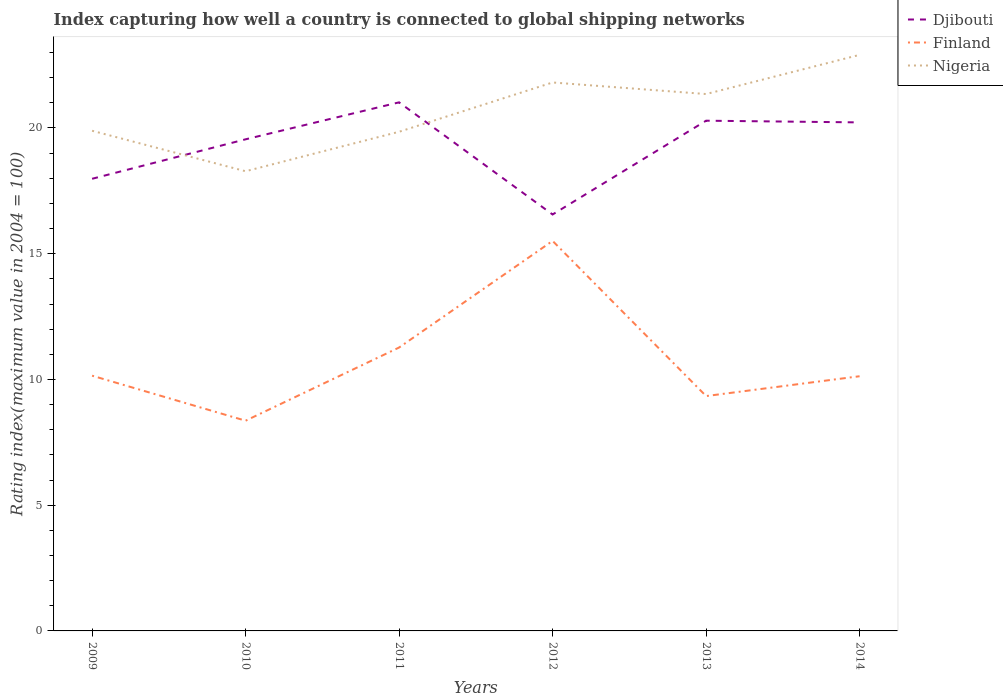Does the line corresponding to Finland intersect with the line corresponding to Djibouti?
Ensure brevity in your answer.  No. Across all years, what is the maximum rating index in Nigeria?
Offer a terse response. 18.28. What is the total rating index in Djibouti in the graph?
Make the answer very short. -2.24. What is the difference between the highest and the second highest rating index in Nigeria?
Your response must be concise. 4.63. What is the difference between the highest and the lowest rating index in Djibouti?
Your answer should be very brief. 4. How many years are there in the graph?
Offer a terse response. 6. What is the difference between two consecutive major ticks on the Y-axis?
Offer a very short reply. 5. Does the graph contain grids?
Your response must be concise. No. Where does the legend appear in the graph?
Ensure brevity in your answer.  Top right. What is the title of the graph?
Provide a succinct answer. Index capturing how well a country is connected to global shipping networks. Does "High income" appear as one of the legend labels in the graph?
Provide a succinct answer. No. What is the label or title of the Y-axis?
Provide a short and direct response. Rating index(maximum value in 2004 = 100). What is the Rating index(maximum value in 2004 = 100) in Djibouti in 2009?
Keep it short and to the point. 17.98. What is the Rating index(maximum value in 2004 = 100) of Finland in 2009?
Your answer should be very brief. 10.15. What is the Rating index(maximum value in 2004 = 100) in Nigeria in 2009?
Keep it short and to the point. 19.89. What is the Rating index(maximum value in 2004 = 100) of Djibouti in 2010?
Make the answer very short. 19.55. What is the Rating index(maximum value in 2004 = 100) of Finland in 2010?
Make the answer very short. 8.36. What is the Rating index(maximum value in 2004 = 100) of Nigeria in 2010?
Offer a terse response. 18.28. What is the Rating index(maximum value in 2004 = 100) in Djibouti in 2011?
Keep it short and to the point. 21.02. What is the Rating index(maximum value in 2004 = 100) in Finland in 2011?
Offer a very short reply. 11.27. What is the Rating index(maximum value in 2004 = 100) of Nigeria in 2011?
Provide a short and direct response. 19.85. What is the Rating index(maximum value in 2004 = 100) in Djibouti in 2012?
Keep it short and to the point. 16.56. What is the Rating index(maximum value in 2004 = 100) of Finland in 2012?
Your answer should be compact. 15.51. What is the Rating index(maximum value in 2004 = 100) of Nigeria in 2012?
Make the answer very short. 21.81. What is the Rating index(maximum value in 2004 = 100) in Djibouti in 2013?
Make the answer very short. 20.29. What is the Rating index(maximum value in 2004 = 100) of Finland in 2013?
Offer a terse response. 9.34. What is the Rating index(maximum value in 2004 = 100) in Nigeria in 2013?
Your answer should be compact. 21.35. What is the Rating index(maximum value in 2004 = 100) in Djibouti in 2014?
Your response must be concise. 20.22. What is the Rating index(maximum value in 2004 = 100) in Finland in 2014?
Offer a terse response. 10.13. What is the Rating index(maximum value in 2004 = 100) of Nigeria in 2014?
Your response must be concise. 22.91. Across all years, what is the maximum Rating index(maximum value in 2004 = 100) of Djibouti?
Provide a short and direct response. 21.02. Across all years, what is the maximum Rating index(maximum value in 2004 = 100) of Finland?
Ensure brevity in your answer.  15.51. Across all years, what is the maximum Rating index(maximum value in 2004 = 100) of Nigeria?
Provide a short and direct response. 22.91. Across all years, what is the minimum Rating index(maximum value in 2004 = 100) in Djibouti?
Make the answer very short. 16.56. Across all years, what is the minimum Rating index(maximum value in 2004 = 100) in Finland?
Make the answer very short. 8.36. Across all years, what is the minimum Rating index(maximum value in 2004 = 100) of Nigeria?
Your answer should be very brief. 18.28. What is the total Rating index(maximum value in 2004 = 100) in Djibouti in the graph?
Offer a terse response. 115.62. What is the total Rating index(maximum value in 2004 = 100) in Finland in the graph?
Offer a very short reply. 64.76. What is the total Rating index(maximum value in 2004 = 100) in Nigeria in the graph?
Your answer should be compact. 124.09. What is the difference between the Rating index(maximum value in 2004 = 100) in Djibouti in 2009 and that in 2010?
Your answer should be compact. -1.57. What is the difference between the Rating index(maximum value in 2004 = 100) of Finland in 2009 and that in 2010?
Provide a succinct answer. 1.79. What is the difference between the Rating index(maximum value in 2004 = 100) in Nigeria in 2009 and that in 2010?
Offer a terse response. 1.61. What is the difference between the Rating index(maximum value in 2004 = 100) in Djibouti in 2009 and that in 2011?
Provide a succinct answer. -3.04. What is the difference between the Rating index(maximum value in 2004 = 100) in Finland in 2009 and that in 2011?
Make the answer very short. -1.12. What is the difference between the Rating index(maximum value in 2004 = 100) in Nigeria in 2009 and that in 2011?
Give a very brief answer. 0.04. What is the difference between the Rating index(maximum value in 2004 = 100) of Djibouti in 2009 and that in 2012?
Provide a succinct answer. 1.42. What is the difference between the Rating index(maximum value in 2004 = 100) in Finland in 2009 and that in 2012?
Your answer should be very brief. -5.36. What is the difference between the Rating index(maximum value in 2004 = 100) of Nigeria in 2009 and that in 2012?
Offer a very short reply. -1.92. What is the difference between the Rating index(maximum value in 2004 = 100) of Djibouti in 2009 and that in 2013?
Offer a very short reply. -2.31. What is the difference between the Rating index(maximum value in 2004 = 100) in Finland in 2009 and that in 2013?
Provide a succinct answer. 0.81. What is the difference between the Rating index(maximum value in 2004 = 100) of Nigeria in 2009 and that in 2013?
Ensure brevity in your answer.  -1.46. What is the difference between the Rating index(maximum value in 2004 = 100) of Djibouti in 2009 and that in 2014?
Your response must be concise. -2.24. What is the difference between the Rating index(maximum value in 2004 = 100) of Finland in 2009 and that in 2014?
Make the answer very short. 0.02. What is the difference between the Rating index(maximum value in 2004 = 100) of Nigeria in 2009 and that in 2014?
Provide a succinct answer. -3.02. What is the difference between the Rating index(maximum value in 2004 = 100) of Djibouti in 2010 and that in 2011?
Your answer should be very brief. -1.47. What is the difference between the Rating index(maximum value in 2004 = 100) of Finland in 2010 and that in 2011?
Offer a very short reply. -2.91. What is the difference between the Rating index(maximum value in 2004 = 100) of Nigeria in 2010 and that in 2011?
Make the answer very short. -1.57. What is the difference between the Rating index(maximum value in 2004 = 100) of Djibouti in 2010 and that in 2012?
Your answer should be very brief. 2.99. What is the difference between the Rating index(maximum value in 2004 = 100) in Finland in 2010 and that in 2012?
Ensure brevity in your answer.  -7.15. What is the difference between the Rating index(maximum value in 2004 = 100) of Nigeria in 2010 and that in 2012?
Keep it short and to the point. -3.53. What is the difference between the Rating index(maximum value in 2004 = 100) of Djibouti in 2010 and that in 2013?
Your response must be concise. -0.74. What is the difference between the Rating index(maximum value in 2004 = 100) of Finland in 2010 and that in 2013?
Ensure brevity in your answer.  -0.98. What is the difference between the Rating index(maximum value in 2004 = 100) of Nigeria in 2010 and that in 2013?
Offer a terse response. -3.07. What is the difference between the Rating index(maximum value in 2004 = 100) of Djibouti in 2010 and that in 2014?
Your answer should be very brief. -0.67. What is the difference between the Rating index(maximum value in 2004 = 100) in Finland in 2010 and that in 2014?
Your answer should be compact. -1.77. What is the difference between the Rating index(maximum value in 2004 = 100) in Nigeria in 2010 and that in 2014?
Provide a short and direct response. -4.63. What is the difference between the Rating index(maximum value in 2004 = 100) of Djibouti in 2011 and that in 2012?
Your answer should be very brief. 4.46. What is the difference between the Rating index(maximum value in 2004 = 100) of Finland in 2011 and that in 2012?
Ensure brevity in your answer.  -4.24. What is the difference between the Rating index(maximum value in 2004 = 100) of Nigeria in 2011 and that in 2012?
Your answer should be compact. -1.96. What is the difference between the Rating index(maximum value in 2004 = 100) of Djibouti in 2011 and that in 2013?
Ensure brevity in your answer.  0.73. What is the difference between the Rating index(maximum value in 2004 = 100) of Finland in 2011 and that in 2013?
Your response must be concise. 1.93. What is the difference between the Rating index(maximum value in 2004 = 100) in Nigeria in 2011 and that in 2013?
Make the answer very short. -1.5. What is the difference between the Rating index(maximum value in 2004 = 100) in Djibouti in 2011 and that in 2014?
Provide a short and direct response. 0.8. What is the difference between the Rating index(maximum value in 2004 = 100) of Finland in 2011 and that in 2014?
Your response must be concise. 1.14. What is the difference between the Rating index(maximum value in 2004 = 100) in Nigeria in 2011 and that in 2014?
Provide a short and direct response. -3.06. What is the difference between the Rating index(maximum value in 2004 = 100) in Djibouti in 2012 and that in 2013?
Your answer should be compact. -3.73. What is the difference between the Rating index(maximum value in 2004 = 100) in Finland in 2012 and that in 2013?
Keep it short and to the point. 6.17. What is the difference between the Rating index(maximum value in 2004 = 100) in Nigeria in 2012 and that in 2013?
Keep it short and to the point. 0.46. What is the difference between the Rating index(maximum value in 2004 = 100) in Djibouti in 2012 and that in 2014?
Ensure brevity in your answer.  -3.66. What is the difference between the Rating index(maximum value in 2004 = 100) in Finland in 2012 and that in 2014?
Ensure brevity in your answer.  5.38. What is the difference between the Rating index(maximum value in 2004 = 100) in Nigeria in 2012 and that in 2014?
Ensure brevity in your answer.  -1.1. What is the difference between the Rating index(maximum value in 2004 = 100) of Djibouti in 2013 and that in 2014?
Keep it short and to the point. 0.07. What is the difference between the Rating index(maximum value in 2004 = 100) of Finland in 2013 and that in 2014?
Provide a succinct answer. -0.79. What is the difference between the Rating index(maximum value in 2004 = 100) in Nigeria in 2013 and that in 2014?
Keep it short and to the point. -1.56. What is the difference between the Rating index(maximum value in 2004 = 100) in Djibouti in 2009 and the Rating index(maximum value in 2004 = 100) in Finland in 2010?
Provide a short and direct response. 9.62. What is the difference between the Rating index(maximum value in 2004 = 100) in Djibouti in 2009 and the Rating index(maximum value in 2004 = 100) in Nigeria in 2010?
Provide a succinct answer. -0.3. What is the difference between the Rating index(maximum value in 2004 = 100) in Finland in 2009 and the Rating index(maximum value in 2004 = 100) in Nigeria in 2010?
Provide a short and direct response. -8.13. What is the difference between the Rating index(maximum value in 2004 = 100) of Djibouti in 2009 and the Rating index(maximum value in 2004 = 100) of Finland in 2011?
Offer a very short reply. 6.71. What is the difference between the Rating index(maximum value in 2004 = 100) of Djibouti in 2009 and the Rating index(maximum value in 2004 = 100) of Nigeria in 2011?
Your answer should be compact. -1.87. What is the difference between the Rating index(maximum value in 2004 = 100) in Finland in 2009 and the Rating index(maximum value in 2004 = 100) in Nigeria in 2011?
Ensure brevity in your answer.  -9.7. What is the difference between the Rating index(maximum value in 2004 = 100) of Djibouti in 2009 and the Rating index(maximum value in 2004 = 100) of Finland in 2012?
Keep it short and to the point. 2.47. What is the difference between the Rating index(maximum value in 2004 = 100) of Djibouti in 2009 and the Rating index(maximum value in 2004 = 100) of Nigeria in 2012?
Your answer should be compact. -3.83. What is the difference between the Rating index(maximum value in 2004 = 100) of Finland in 2009 and the Rating index(maximum value in 2004 = 100) of Nigeria in 2012?
Provide a succinct answer. -11.66. What is the difference between the Rating index(maximum value in 2004 = 100) of Djibouti in 2009 and the Rating index(maximum value in 2004 = 100) of Finland in 2013?
Offer a terse response. 8.64. What is the difference between the Rating index(maximum value in 2004 = 100) of Djibouti in 2009 and the Rating index(maximum value in 2004 = 100) of Nigeria in 2013?
Make the answer very short. -3.37. What is the difference between the Rating index(maximum value in 2004 = 100) in Djibouti in 2009 and the Rating index(maximum value in 2004 = 100) in Finland in 2014?
Your answer should be very brief. 7.85. What is the difference between the Rating index(maximum value in 2004 = 100) in Djibouti in 2009 and the Rating index(maximum value in 2004 = 100) in Nigeria in 2014?
Provide a succinct answer. -4.93. What is the difference between the Rating index(maximum value in 2004 = 100) of Finland in 2009 and the Rating index(maximum value in 2004 = 100) of Nigeria in 2014?
Provide a succinct answer. -12.76. What is the difference between the Rating index(maximum value in 2004 = 100) in Djibouti in 2010 and the Rating index(maximum value in 2004 = 100) in Finland in 2011?
Keep it short and to the point. 8.28. What is the difference between the Rating index(maximum value in 2004 = 100) in Finland in 2010 and the Rating index(maximum value in 2004 = 100) in Nigeria in 2011?
Your answer should be compact. -11.49. What is the difference between the Rating index(maximum value in 2004 = 100) in Djibouti in 2010 and the Rating index(maximum value in 2004 = 100) in Finland in 2012?
Keep it short and to the point. 4.04. What is the difference between the Rating index(maximum value in 2004 = 100) in Djibouti in 2010 and the Rating index(maximum value in 2004 = 100) in Nigeria in 2012?
Your answer should be very brief. -2.26. What is the difference between the Rating index(maximum value in 2004 = 100) of Finland in 2010 and the Rating index(maximum value in 2004 = 100) of Nigeria in 2012?
Make the answer very short. -13.45. What is the difference between the Rating index(maximum value in 2004 = 100) in Djibouti in 2010 and the Rating index(maximum value in 2004 = 100) in Finland in 2013?
Make the answer very short. 10.21. What is the difference between the Rating index(maximum value in 2004 = 100) in Finland in 2010 and the Rating index(maximum value in 2004 = 100) in Nigeria in 2013?
Offer a very short reply. -12.99. What is the difference between the Rating index(maximum value in 2004 = 100) in Djibouti in 2010 and the Rating index(maximum value in 2004 = 100) in Finland in 2014?
Keep it short and to the point. 9.42. What is the difference between the Rating index(maximum value in 2004 = 100) in Djibouti in 2010 and the Rating index(maximum value in 2004 = 100) in Nigeria in 2014?
Your answer should be very brief. -3.36. What is the difference between the Rating index(maximum value in 2004 = 100) of Finland in 2010 and the Rating index(maximum value in 2004 = 100) of Nigeria in 2014?
Make the answer very short. -14.55. What is the difference between the Rating index(maximum value in 2004 = 100) of Djibouti in 2011 and the Rating index(maximum value in 2004 = 100) of Finland in 2012?
Ensure brevity in your answer.  5.51. What is the difference between the Rating index(maximum value in 2004 = 100) in Djibouti in 2011 and the Rating index(maximum value in 2004 = 100) in Nigeria in 2012?
Offer a very short reply. -0.79. What is the difference between the Rating index(maximum value in 2004 = 100) of Finland in 2011 and the Rating index(maximum value in 2004 = 100) of Nigeria in 2012?
Ensure brevity in your answer.  -10.54. What is the difference between the Rating index(maximum value in 2004 = 100) of Djibouti in 2011 and the Rating index(maximum value in 2004 = 100) of Finland in 2013?
Keep it short and to the point. 11.68. What is the difference between the Rating index(maximum value in 2004 = 100) in Djibouti in 2011 and the Rating index(maximum value in 2004 = 100) in Nigeria in 2013?
Make the answer very short. -0.33. What is the difference between the Rating index(maximum value in 2004 = 100) of Finland in 2011 and the Rating index(maximum value in 2004 = 100) of Nigeria in 2013?
Offer a very short reply. -10.08. What is the difference between the Rating index(maximum value in 2004 = 100) of Djibouti in 2011 and the Rating index(maximum value in 2004 = 100) of Finland in 2014?
Your answer should be very brief. 10.89. What is the difference between the Rating index(maximum value in 2004 = 100) in Djibouti in 2011 and the Rating index(maximum value in 2004 = 100) in Nigeria in 2014?
Make the answer very short. -1.89. What is the difference between the Rating index(maximum value in 2004 = 100) in Finland in 2011 and the Rating index(maximum value in 2004 = 100) in Nigeria in 2014?
Provide a short and direct response. -11.64. What is the difference between the Rating index(maximum value in 2004 = 100) of Djibouti in 2012 and the Rating index(maximum value in 2004 = 100) of Finland in 2013?
Provide a succinct answer. 7.22. What is the difference between the Rating index(maximum value in 2004 = 100) of Djibouti in 2012 and the Rating index(maximum value in 2004 = 100) of Nigeria in 2013?
Ensure brevity in your answer.  -4.79. What is the difference between the Rating index(maximum value in 2004 = 100) of Finland in 2012 and the Rating index(maximum value in 2004 = 100) of Nigeria in 2013?
Provide a short and direct response. -5.84. What is the difference between the Rating index(maximum value in 2004 = 100) in Djibouti in 2012 and the Rating index(maximum value in 2004 = 100) in Finland in 2014?
Provide a short and direct response. 6.43. What is the difference between the Rating index(maximum value in 2004 = 100) of Djibouti in 2012 and the Rating index(maximum value in 2004 = 100) of Nigeria in 2014?
Make the answer very short. -6.35. What is the difference between the Rating index(maximum value in 2004 = 100) in Finland in 2012 and the Rating index(maximum value in 2004 = 100) in Nigeria in 2014?
Your response must be concise. -7.4. What is the difference between the Rating index(maximum value in 2004 = 100) of Djibouti in 2013 and the Rating index(maximum value in 2004 = 100) of Finland in 2014?
Your answer should be compact. 10.16. What is the difference between the Rating index(maximum value in 2004 = 100) of Djibouti in 2013 and the Rating index(maximum value in 2004 = 100) of Nigeria in 2014?
Give a very brief answer. -2.62. What is the difference between the Rating index(maximum value in 2004 = 100) of Finland in 2013 and the Rating index(maximum value in 2004 = 100) of Nigeria in 2014?
Make the answer very short. -13.57. What is the average Rating index(maximum value in 2004 = 100) of Djibouti per year?
Your answer should be compact. 19.27. What is the average Rating index(maximum value in 2004 = 100) of Finland per year?
Give a very brief answer. 10.79. What is the average Rating index(maximum value in 2004 = 100) of Nigeria per year?
Ensure brevity in your answer.  20.68. In the year 2009, what is the difference between the Rating index(maximum value in 2004 = 100) in Djibouti and Rating index(maximum value in 2004 = 100) in Finland?
Your response must be concise. 7.83. In the year 2009, what is the difference between the Rating index(maximum value in 2004 = 100) in Djibouti and Rating index(maximum value in 2004 = 100) in Nigeria?
Ensure brevity in your answer.  -1.91. In the year 2009, what is the difference between the Rating index(maximum value in 2004 = 100) of Finland and Rating index(maximum value in 2004 = 100) of Nigeria?
Ensure brevity in your answer.  -9.74. In the year 2010, what is the difference between the Rating index(maximum value in 2004 = 100) of Djibouti and Rating index(maximum value in 2004 = 100) of Finland?
Offer a terse response. 11.19. In the year 2010, what is the difference between the Rating index(maximum value in 2004 = 100) in Djibouti and Rating index(maximum value in 2004 = 100) in Nigeria?
Offer a very short reply. 1.27. In the year 2010, what is the difference between the Rating index(maximum value in 2004 = 100) of Finland and Rating index(maximum value in 2004 = 100) of Nigeria?
Provide a short and direct response. -9.92. In the year 2011, what is the difference between the Rating index(maximum value in 2004 = 100) in Djibouti and Rating index(maximum value in 2004 = 100) in Finland?
Your response must be concise. 9.75. In the year 2011, what is the difference between the Rating index(maximum value in 2004 = 100) in Djibouti and Rating index(maximum value in 2004 = 100) in Nigeria?
Offer a terse response. 1.17. In the year 2011, what is the difference between the Rating index(maximum value in 2004 = 100) in Finland and Rating index(maximum value in 2004 = 100) in Nigeria?
Ensure brevity in your answer.  -8.58. In the year 2012, what is the difference between the Rating index(maximum value in 2004 = 100) of Djibouti and Rating index(maximum value in 2004 = 100) of Finland?
Ensure brevity in your answer.  1.05. In the year 2012, what is the difference between the Rating index(maximum value in 2004 = 100) of Djibouti and Rating index(maximum value in 2004 = 100) of Nigeria?
Your answer should be compact. -5.25. In the year 2012, what is the difference between the Rating index(maximum value in 2004 = 100) in Finland and Rating index(maximum value in 2004 = 100) in Nigeria?
Ensure brevity in your answer.  -6.3. In the year 2013, what is the difference between the Rating index(maximum value in 2004 = 100) in Djibouti and Rating index(maximum value in 2004 = 100) in Finland?
Offer a terse response. 10.95. In the year 2013, what is the difference between the Rating index(maximum value in 2004 = 100) of Djibouti and Rating index(maximum value in 2004 = 100) of Nigeria?
Provide a short and direct response. -1.06. In the year 2013, what is the difference between the Rating index(maximum value in 2004 = 100) of Finland and Rating index(maximum value in 2004 = 100) of Nigeria?
Provide a succinct answer. -12.01. In the year 2014, what is the difference between the Rating index(maximum value in 2004 = 100) of Djibouti and Rating index(maximum value in 2004 = 100) of Finland?
Provide a succinct answer. 10.09. In the year 2014, what is the difference between the Rating index(maximum value in 2004 = 100) of Djibouti and Rating index(maximum value in 2004 = 100) of Nigeria?
Make the answer very short. -2.69. In the year 2014, what is the difference between the Rating index(maximum value in 2004 = 100) in Finland and Rating index(maximum value in 2004 = 100) in Nigeria?
Your answer should be very brief. -12.78. What is the ratio of the Rating index(maximum value in 2004 = 100) of Djibouti in 2009 to that in 2010?
Give a very brief answer. 0.92. What is the ratio of the Rating index(maximum value in 2004 = 100) in Finland in 2009 to that in 2010?
Ensure brevity in your answer.  1.21. What is the ratio of the Rating index(maximum value in 2004 = 100) in Nigeria in 2009 to that in 2010?
Offer a terse response. 1.09. What is the ratio of the Rating index(maximum value in 2004 = 100) of Djibouti in 2009 to that in 2011?
Offer a terse response. 0.86. What is the ratio of the Rating index(maximum value in 2004 = 100) of Finland in 2009 to that in 2011?
Ensure brevity in your answer.  0.9. What is the ratio of the Rating index(maximum value in 2004 = 100) in Nigeria in 2009 to that in 2011?
Provide a succinct answer. 1. What is the ratio of the Rating index(maximum value in 2004 = 100) in Djibouti in 2009 to that in 2012?
Your answer should be compact. 1.09. What is the ratio of the Rating index(maximum value in 2004 = 100) of Finland in 2009 to that in 2012?
Your answer should be very brief. 0.65. What is the ratio of the Rating index(maximum value in 2004 = 100) in Nigeria in 2009 to that in 2012?
Make the answer very short. 0.91. What is the ratio of the Rating index(maximum value in 2004 = 100) of Djibouti in 2009 to that in 2013?
Provide a short and direct response. 0.89. What is the ratio of the Rating index(maximum value in 2004 = 100) in Finland in 2009 to that in 2013?
Your answer should be compact. 1.09. What is the ratio of the Rating index(maximum value in 2004 = 100) of Nigeria in 2009 to that in 2013?
Offer a very short reply. 0.93. What is the ratio of the Rating index(maximum value in 2004 = 100) of Djibouti in 2009 to that in 2014?
Ensure brevity in your answer.  0.89. What is the ratio of the Rating index(maximum value in 2004 = 100) of Finland in 2009 to that in 2014?
Provide a succinct answer. 1. What is the ratio of the Rating index(maximum value in 2004 = 100) in Nigeria in 2009 to that in 2014?
Ensure brevity in your answer.  0.87. What is the ratio of the Rating index(maximum value in 2004 = 100) of Djibouti in 2010 to that in 2011?
Provide a succinct answer. 0.93. What is the ratio of the Rating index(maximum value in 2004 = 100) of Finland in 2010 to that in 2011?
Make the answer very short. 0.74. What is the ratio of the Rating index(maximum value in 2004 = 100) of Nigeria in 2010 to that in 2011?
Your answer should be compact. 0.92. What is the ratio of the Rating index(maximum value in 2004 = 100) of Djibouti in 2010 to that in 2012?
Make the answer very short. 1.18. What is the ratio of the Rating index(maximum value in 2004 = 100) in Finland in 2010 to that in 2012?
Provide a succinct answer. 0.54. What is the ratio of the Rating index(maximum value in 2004 = 100) of Nigeria in 2010 to that in 2012?
Provide a succinct answer. 0.84. What is the ratio of the Rating index(maximum value in 2004 = 100) of Djibouti in 2010 to that in 2013?
Make the answer very short. 0.96. What is the ratio of the Rating index(maximum value in 2004 = 100) in Finland in 2010 to that in 2013?
Make the answer very short. 0.9. What is the ratio of the Rating index(maximum value in 2004 = 100) of Nigeria in 2010 to that in 2013?
Offer a terse response. 0.86. What is the ratio of the Rating index(maximum value in 2004 = 100) in Djibouti in 2010 to that in 2014?
Keep it short and to the point. 0.97. What is the ratio of the Rating index(maximum value in 2004 = 100) of Finland in 2010 to that in 2014?
Your answer should be very brief. 0.83. What is the ratio of the Rating index(maximum value in 2004 = 100) in Nigeria in 2010 to that in 2014?
Your response must be concise. 0.8. What is the ratio of the Rating index(maximum value in 2004 = 100) of Djibouti in 2011 to that in 2012?
Your response must be concise. 1.27. What is the ratio of the Rating index(maximum value in 2004 = 100) of Finland in 2011 to that in 2012?
Ensure brevity in your answer.  0.73. What is the ratio of the Rating index(maximum value in 2004 = 100) of Nigeria in 2011 to that in 2012?
Make the answer very short. 0.91. What is the ratio of the Rating index(maximum value in 2004 = 100) in Djibouti in 2011 to that in 2013?
Offer a terse response. 1.04. What is the ratio of the Rating index(maximum value in 2004 = 100) in Finland in 2011 to that in 2013?
Provide a short and direct response. 1.21. What is the ratio of the Rating index(maximum value in 2004 = 100) of Nigeria in 2011 to that in 2013?
Your answer should be compact. 0.93. What is the ratio of the Rating index(maximum value in 2004 = 100) of Djibouti in 2011 to that in 2014?
Your response must be concise. 1.04. What is the ratio of the Rating index(maximum value in 2004 = 100) in Finland in 2011 to that in 2014?
Offer a very short reply. 1.11. What is the ratio of the Rating index(maximum value in 2004 = 100) in Nigeria in 2011 to that in 2014?
Keep it short and to the point. 0.87. What is the ratio of the Rating index(maximum value in 2004 = 100) in Djibouti in 2012 to that in 2013?
Provide a short and direct response. 0.82. What is the ratio of the Rating index(maximum value in 2004 = 100) of Finland in 2012 to that in 2013?
Keep it short and to the point. 1.66. What is the ratio of the Rating index(maximum value in 2004 = 100) of Nigeria in 2012 to that in 2013?
Provide a succinct answer. 1.02. What is the ratio of the Rating index(maximum value in 2004 = 100) of Djibouti in 2012 to that in 2014?
Ensure brevity in your answer.  0.82. What is the ratio of the Rating index(maximum value in 2004 = 100) of Finland in 2012 to that in 2014?
Provide a short and direct response. 1.53. What is the ratio of the Rating index(maximum value in 2004 = 100) of Nigeria in 2012 to that in 2014?
Provide a succinct answer. 0.95. What is the ratio of the Rating index(maximum value in 2004 = 100) in Djibouti in 2013 to that in 2014?
Ensure brevity in your answer.  1. What is the ratio of the Rating index(maximum value in 2004 = 100) of Finland in 2013 to that in 2014?
Keep it short and to the point. 0.92. What is the ratio of the Rating index(maximum value in 2004 = 100) of Nigeria in 2013 to that in 2014?
Your answer should be very brief. 0.93. What is the difference between the highest and the second highest Rating index(maximum value in 2004 = 100) in Djibouti?
Your answer should be compact. 0.73. What is the difference between the highest and the second highest Rating index(maximum value in 2004 = 100) of Finland?
Give a very brief answer. 4.24. What is the difference between the highest and the second highest Rating index(maximum value in 2004 = 100) of Nigeria?
Offer a terse response. 1.1. What is the difference between the highest and the lowest Rating index(maximum value in 2004 = 100) of Djibouti?
Keep it short and to the point. 4.46. What is the difference between the highest and the lowest Rating index(maximum value in 2004 = 100) in Finland?
Ensure brevity in your answer.  7.15. What is the difference between the highest and the lowest Rating index(maximum value in 2004 = 100) of Nigeria?
Keep it short and to the point. 4.63. 